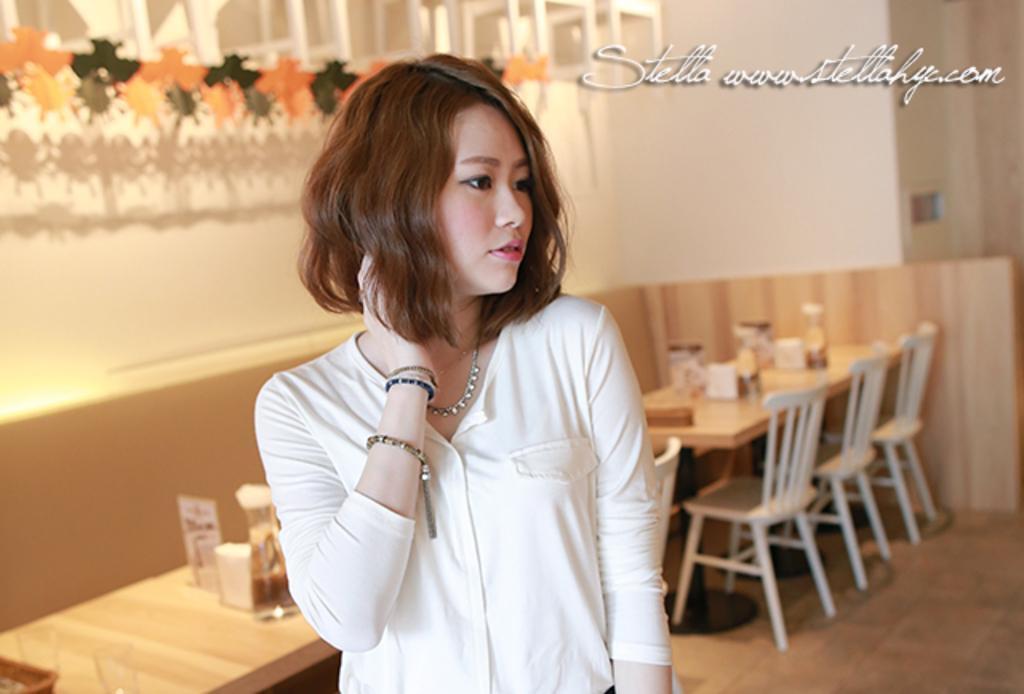Could you give a brief overview of what you see in this image? There is a girl with white shirt standing in the room. There are glasses, bottles, tissues on the table and there are chairs at the back side. 